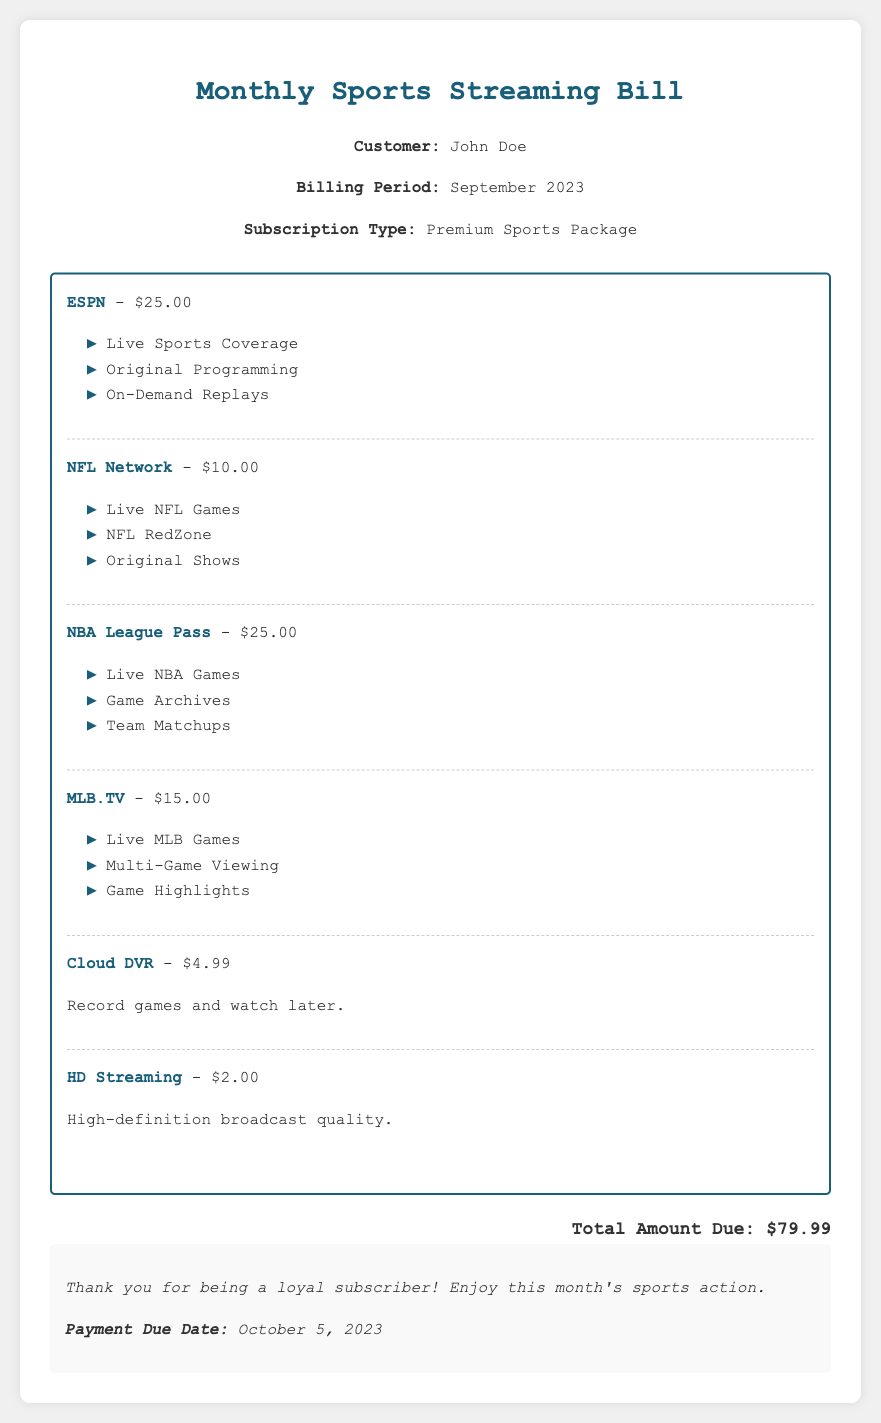What is the customer's name? The document states that the customer's name is John Doe.
Answer: John Doe What is the total amount due? The total amount due is explicitly mentioned in the document as $79.99.
Answer: $79.99 What is the billing period? The billing period is specified in the document as September 2023.
Answer: September 2023 How much is the NBA League Pass? The cost of the NBA League Pass is provided as $25.00 in the breakdown.
Answer: $25.00 What features are included with Cloud DVR? The features for Cloud DVR include the ability to record games and watch later.
Answer: Record games and watch later What is the payment due date? The payment due date is noted in the document as October 5, 2023.
Answer: October 5, 2023 How many channels are listed in the breakdown? The breakdown lists a total of six channels and features.
Answer: Six What is the cost of HD Streaming? The document specifies the cost of HD Streaming as $2.00.
Answer: $2.00 What type of subscription does the customer have? The type of subscription is clearly identified as Premium Sports Package.
Answer: Premium Sports Package 